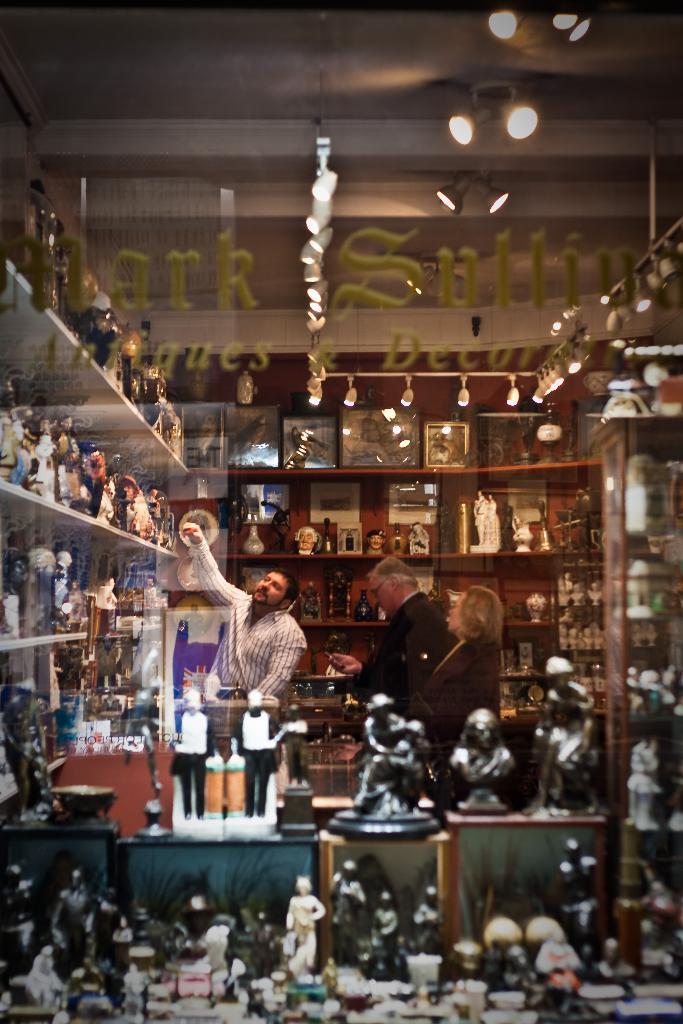Can you describe this image briefly? In this picture there are three persons standing and there are few toys placed on the shelves around them and there are few lights above them. 